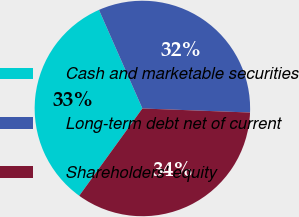<chart> <loc_0><loc_0><loc_500><loc_500><pie_chart><fcel>Cash and marketable securities<fcel>Long-term debt net of current<fcel>Shareholders' equity<nl><fcel>33.43%<fcel>32.2%<fcel>34.37%<nl></chart> 